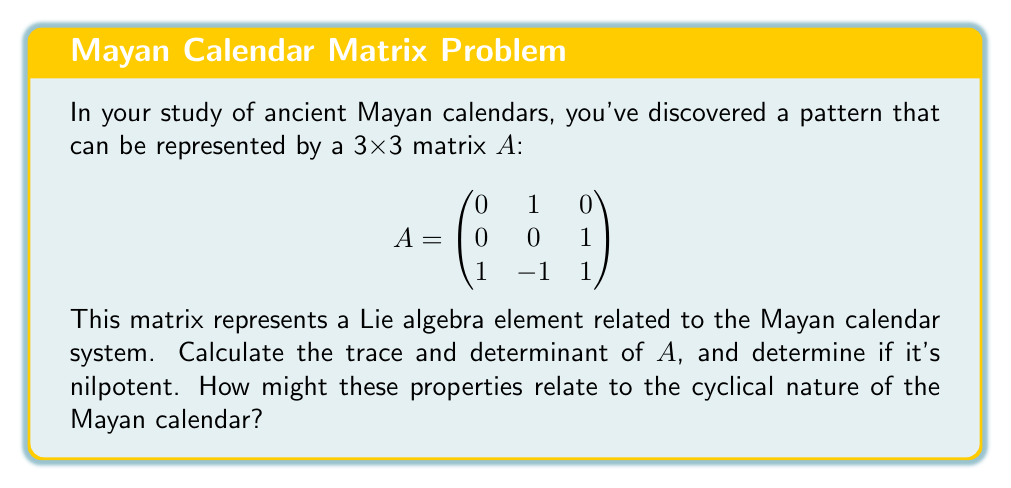Solve this math problem. Let's approach this step-by-step:

1) First, let's calculate the trace of $A$. The trace is the sum of the elements on the main diagonal.

   $\text{tr}(A) = 0 + 0 + 1 = 1$

2) Next, let's calculate the determinant of $A$. We can use the Sarrus' rule for 3x3 matrices:

   $\det(A) = 0(0)(1) + 1(1)(1) + 0(0)(0) - 0(1)(0) - 0(0)(1) - 1(0)(0) = 1$

3) To determine if $A$ is nilpotent, we need to check if there exists a positive integer $k$ such that $A^k = 0$. Let's calculate $A^2$ and $A^3$:

   $A^2 = \begin{pmatrix}
   0 & 0 & 1 \\
   1 & -1 & 1 \\
   0 & 2 & 0
   \end{pmatrix}$

   $A^3 = \begin{pmatrix}
   1 & -1 & 1 \\
   0 & 2 & 0 \\
   1 & -1 & 1
   \end{pmatrix}$

   We can see that $A^3 \neq 0$, and in fact, no power of $A$ will ever be zero because $\det(A) = 1 \neq 0$. Therefore, $A$ is not nilpotent.

4) Relating to the Mayan calendar:
   - The trace being 1 could represent the passage of one time unit in the calendar system.
   - The determinant being 1 indicates that the transformation preserves volume, which could relate to the conservation of time in the calendar system.
   - The non-nilpotency of $A$ suggests that the calendar system doesn't "reset" or "zero out", but continues indefinitely, which aligns with the cyclical nature of the Mayan calendar.
Answer: Trace: 1, Determinant: 1, Not nilpotent. Properties suggest cyclical, non-resetting nature of Mayan calendar. 